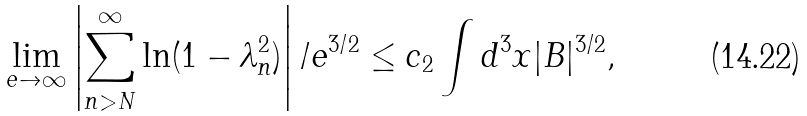<formula> <loc_0><loc_0><loc_500><loc_500>\lim _ { e \to \infty } \left | \sum _ { n > N } ^ { \infty } \ln ( 1 - \lambda _ { n } ^ { 2 } ) \right | / e ^ { 3 / 2 } \leq c _ { 2 } \int d ^ { 3 } x | { B } | ^ { 3 / 2 } ,</formula> 